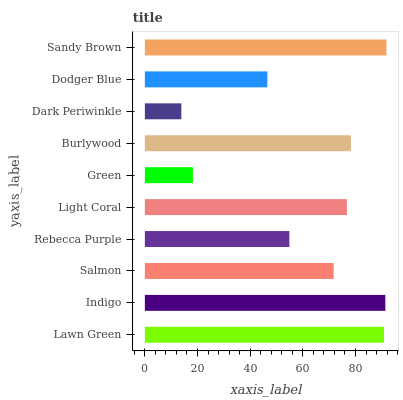Is Dark Periwinkle the minimum?
Answer yes or no. Yes. Is Sandy Brown the maximum?
Answer yes or no. Yes. Is Indigo the minimum?
Answer yes or no. No. Is Indigo the maximum?
Answer yes or no. No. Is Indigo greater than Lawn Green?
Answer yes or no. Yes. Is Lawn Green less than Indigo?
Answer yes or no. Yes. Is Lawn Green greater than Indigo?
Answer yes or no. No. Is Indigo less than Lawn Green?
Answer yes or no. No. Is Light Coral the high median?
Answer yes or no. Yes. Is Salmon the low median?
Answer yes or no. Yes. Is Burlywood the high median?
Answer yes or no. No. Is Rebecca Purple the low median?
Answer yes or no. No. 